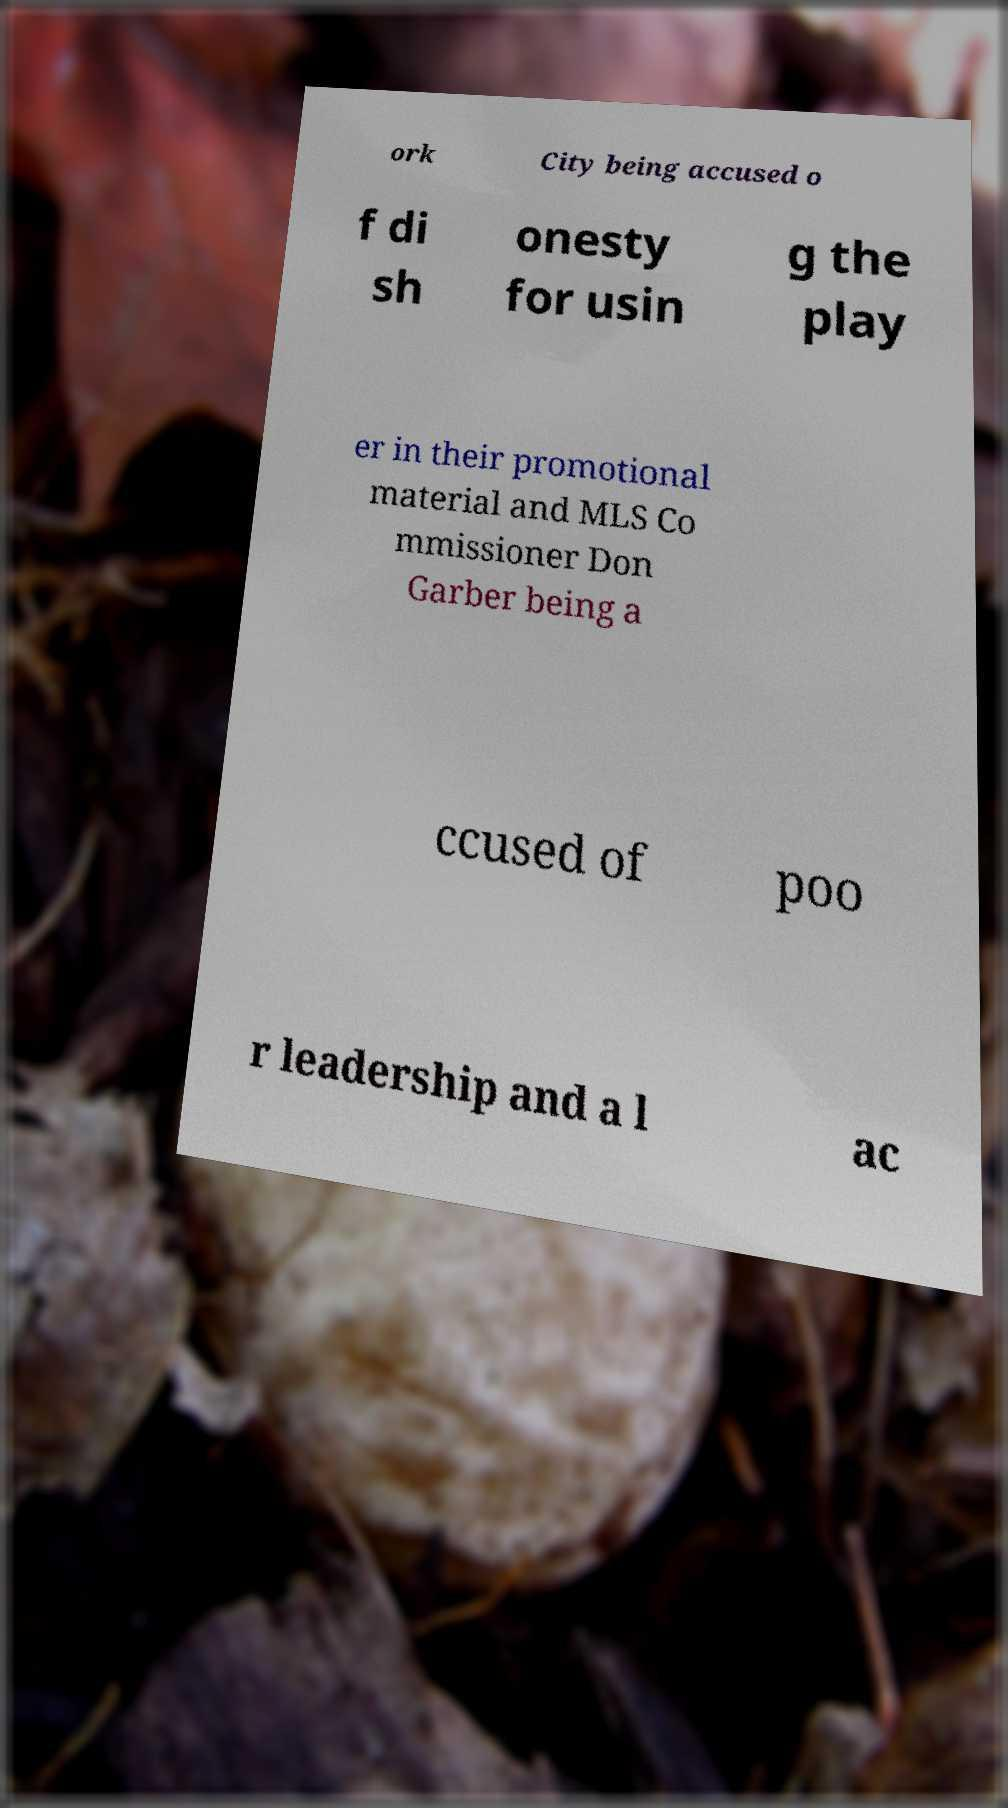Can you accurately transcribe the text from the provided image for me? ork City being accused o f di sh onesty for usin g the play er in their promotional material and MLS Co mmissioner Don Garber being a ccused of poo r leadership and a l ac 